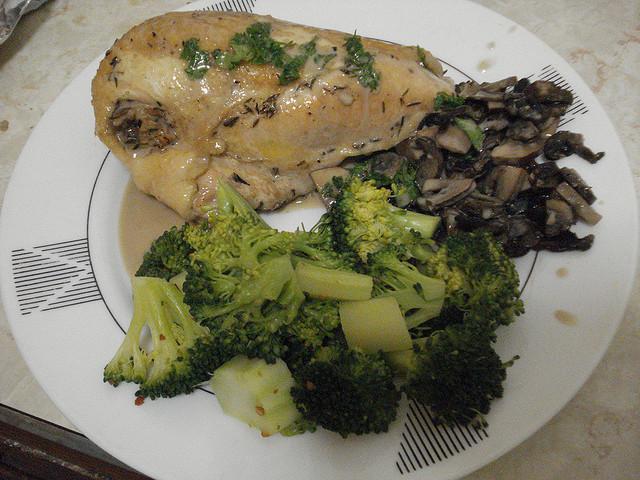How many types are food are on the plate?
Give a very brief answer. 3. 